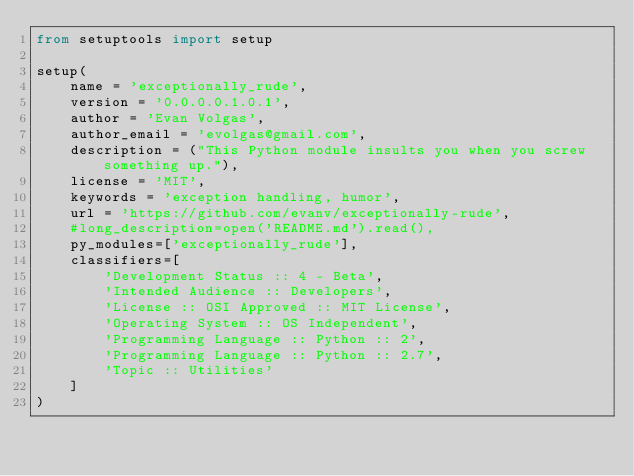Convert code to text. <code><loc_0><loc_0><loc_500><loc_500><_Python_>from setuptools import setup

setup(
    name = 'exceptionally_rude',
    version = '0.0.0.0.1.0.1',
    author = 'Evan Volgas',
    author_email = 'evolgas@gmail.com',
    description = ("This Python module insults you when you screw something up."),
    license = 'MIT',
    keywords = 'exception handling, humor',
    url = 'https://github.com/evanv/exceptionally-rude',
    #long_description=open('README.md').read(),
    py_modules=['exceptionally_rude'],
    classifiers=[
        'Development Status :: 4 - Beta',
        'Intended Audience :: Developers',
        'License :: OSI Approved :: MIT License',
        'Operating System :: OS Independent',
        'Programming Language :: Python :: 2',
        'Programming Language :: Python :: 2.7',
        'Topic :: Utilities'
    ]
)
</code> 